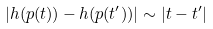<formula> <loc_0><loc_0><loc_500><loc_500>| h ( p ( t ) ) - h ( p ( t ^ { \prime } ) ) | \sim | t - t ^ { \prime } |</formula> 